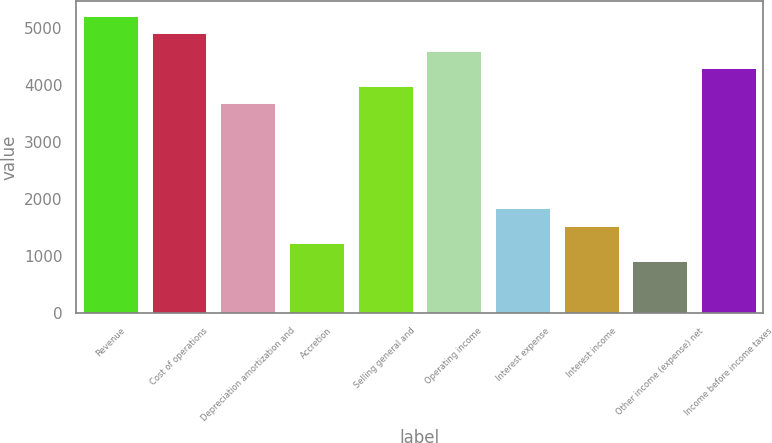Convert chart to OTSL. <chart><loc_0><loc_0><loc_500><loc_500><bar_chart><fcel>Revenue<fcel>Cost of operations<fcel>Depreciation amortization and<fcel>Accretion<fcel>Selling general and<fcel>Operating income<fcel>Interest expense<fcel>Interest income<fcel>Other income (expense) net<fcel>Income before income taxes<nl><fcel>5219.74<fcel>4912.72<fcel>3684.64<fcel>1228.48<fcel>3991.66<fcel>4605.7<fcel>1842.52<fcel>1535.5<fcel>921.46<fcel>4298.68<nl></chart> 